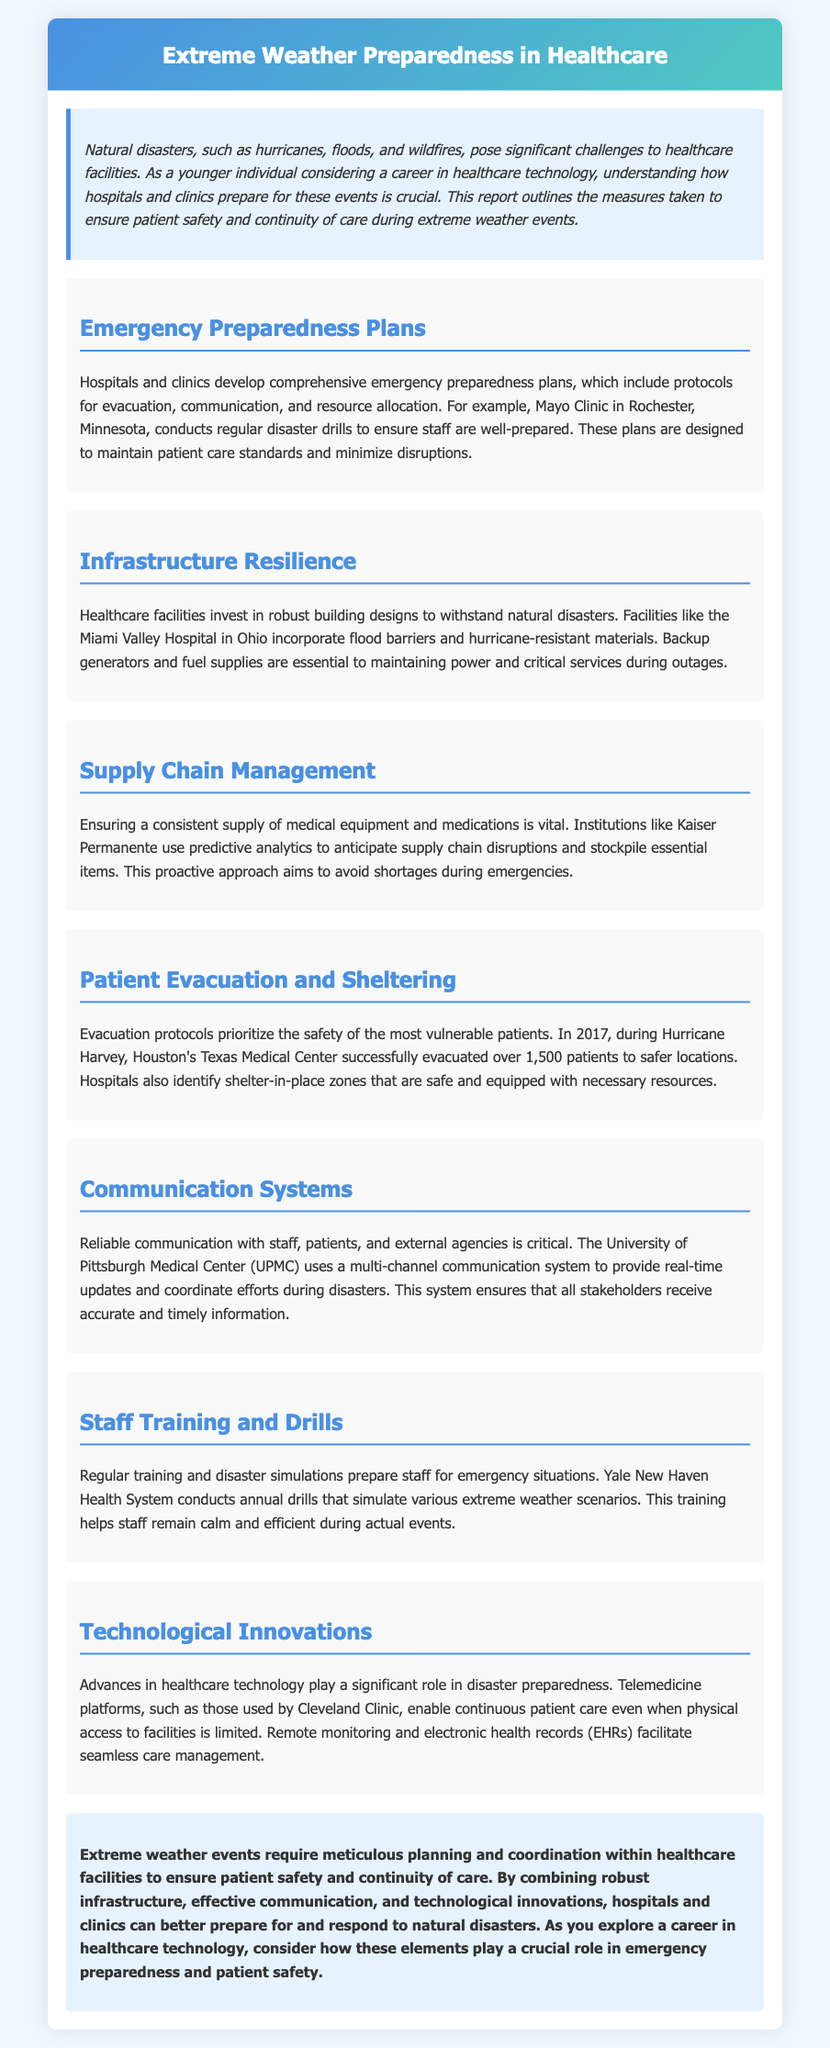What is the title of the report? The title of the report is clearly stated in the header section of the document.
Answer: Extreme Weather Preparedness in Healthcare Which hospital conducts regular disaster drills? The specific example provided in the document highlights that Mayo Clinic conducts regular disaster drills.
Answer: Mayo Clinic What is an example of infrastructure resilience mentioned? The document mentions Miami Valley Hospital incorporating flood barriers and hurricane-resistant materials as part of its infrastructure.
Answer: Flood barriers and hurricane-resistant materials How many patients were evacuated during Hurricane Harvey? The document specifies that Texas Medical Center successfully evacuated over 1,500 patients during Hurricane Harvey.
Answer: Over 1,500 What system does UPMC use for real-time updates? The document describes UPMC utilizing a multi-channel communication system for coordinating efforts during disasters.
Answer: Multi-channel communication system Why is supply chain management important? The text emphasizes that ensuring a consistent supply of medical equipment and medications is vital to avoid shortages during emergencies.
Answer: Avoid shortages during emergencies What type of drills does Yale New Haven Health System conduct? The document states that Yale New Haven Health System conducts annual drills to prepare staff for emergency situations.
Answer: Annual drills What role do technological innovations play in disaster preparedness? The document explains that advances in healthcare technology enable continuous patient care during disasters.
Answer: Continuous patient care 